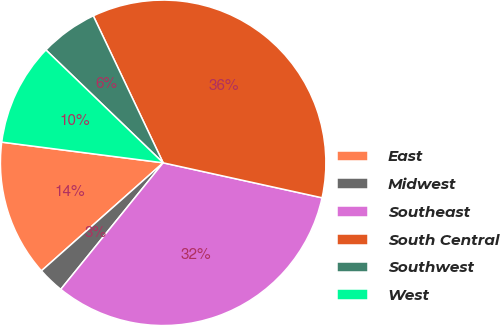<chart> <loc_0><loc_0><loc_500><loc_500><pie_chart><fcel>East<fcel>Midwest<fcel>Southeast<fcel>South Central<fcel>Southwest<fcel>West<nl><fcel>13.58%<fcel>2.62%<fcel>32.38%<fcel>35.51%<fcel>5.74%<fcel>10.17%<nl></chart> 